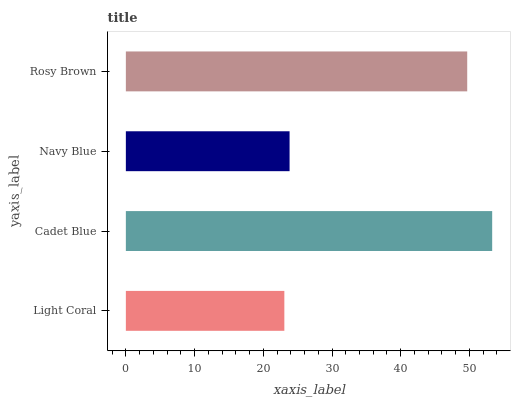Is Light Coral the minimum?
Answer yes or no. Yes. Is Cadet Blue the maximum?
Answer yes or no. Yes. Is Navy Blue the minimum?
Answer yes or no. No. Is Navy Blue the maximum?
Answer yes or no. No. Is Cadet Blue greater than Navy Blue?
Answer yes or no. Yes. Is Navy Blue less than Cadet Blue?
Answer yes or no. Yes. Is Navy Blue greater than Cadet Blue?
Answer yes or no. No. Is Cadet Blue less than Navy Blue?
Answer yes or no. No. Is Rosy Brown the high median?
Answer yes or no. Yes. Is Navy Blue the low median?
Answer yes or no. Yes. Is Light Coral the high median?
Answer yes or no. No. Is Light Coral the low median?
Answer yes or no. No. 